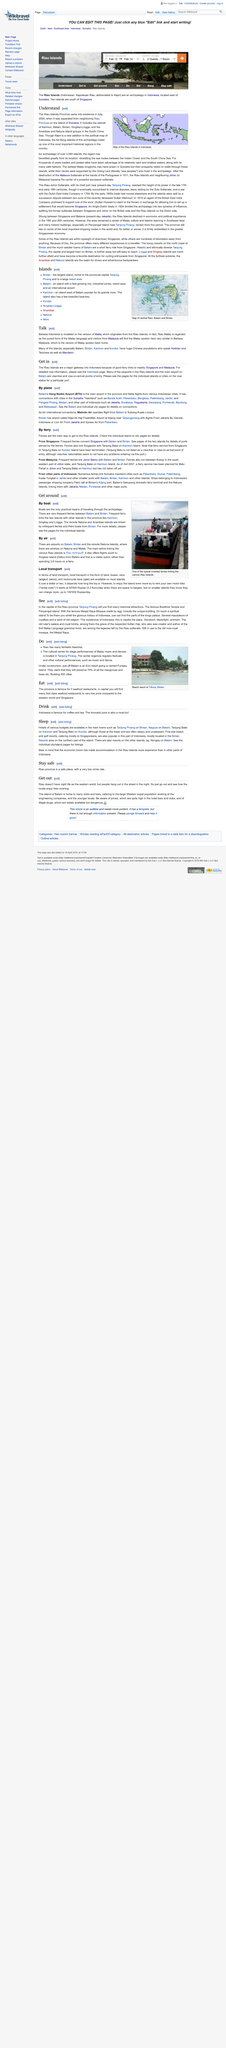Highlight a few significant elements in this photo. The seaports in the Riau Islands are visa-free for many visitors. Singapore and Malaysia have ferries connecting them to the Riau Islands, and these two countries are the only ones with such connections. The ferry service for Batu Pahat in Johor has not yet begun operating. Flights from Batam, Indonesia, to Subang-Kuala Lumpur, operated by Malindo Air, are available for international connections. According to the article "By plane," Batam's Hang Nadim Airport (BTH) is the main airport in the province of Riau Islands. 